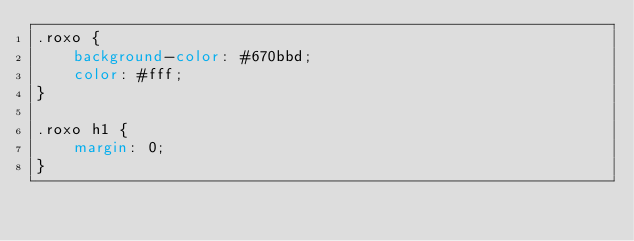<code> <loc_0><loc_0><loc_500><loc_500><_CSS_>.roxo {
    background-color: #670bbd;
    color: #fff;
}

.roxo h1 {
    margin: 0;
}</code> 